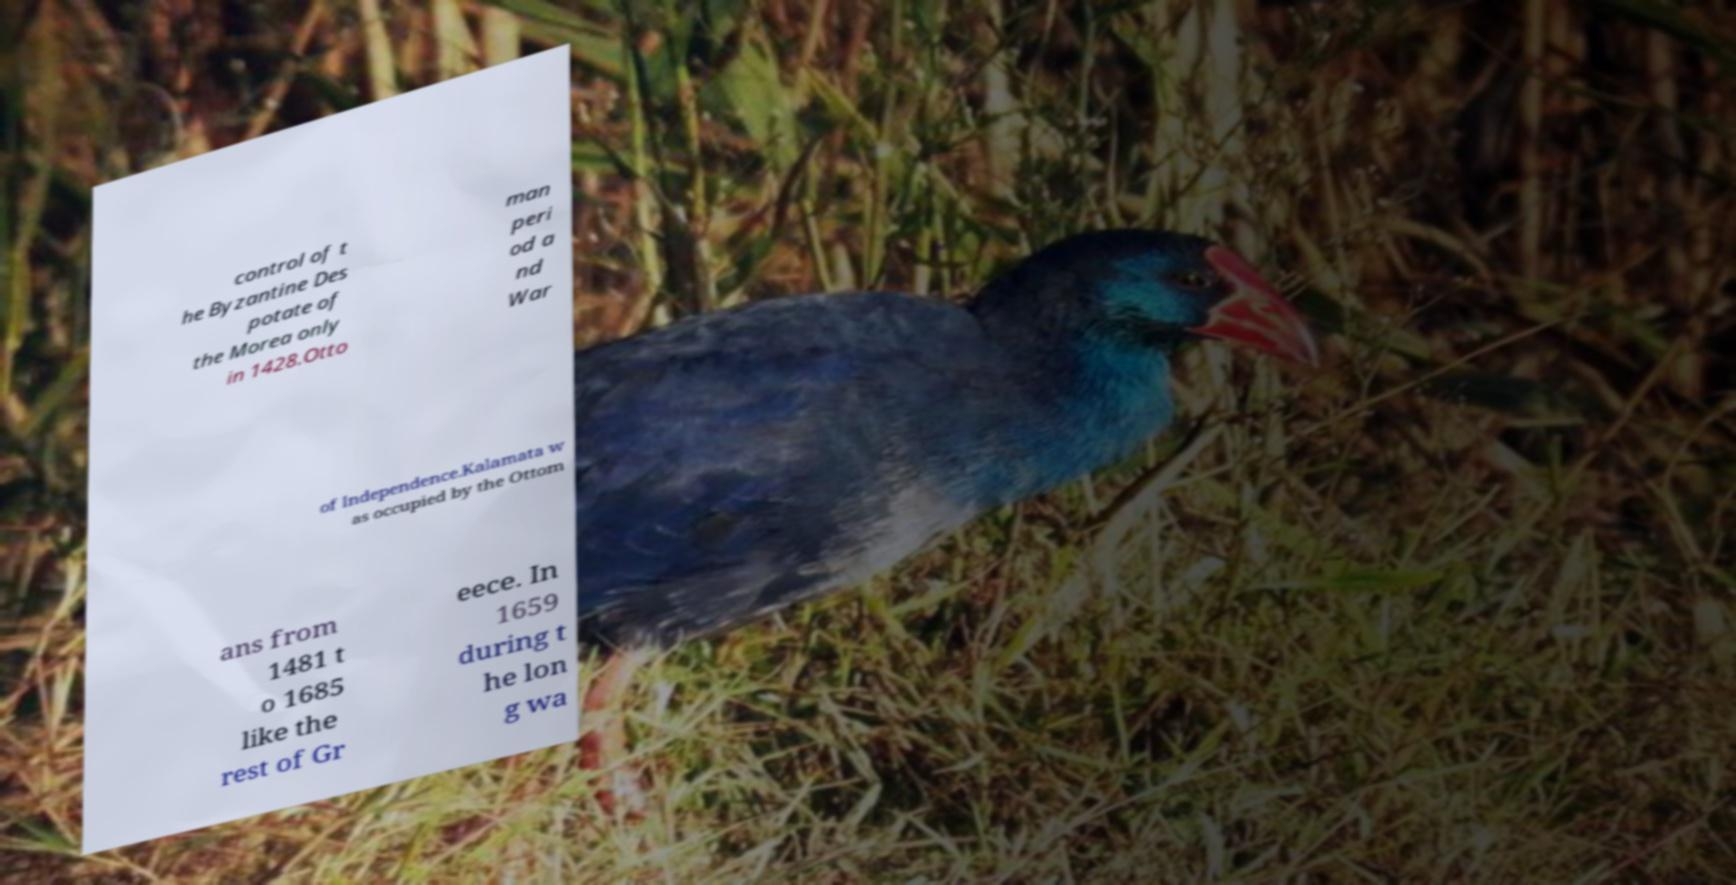Could you assist in decoding the text presented in this image and type it out clearly? control of t he Byzantine Des potate of the Morea only in 1428.Otto man peri od a nd War of Independence.Kalamata w as occupied by the Ottom ans from 1481 t o 1685 like the rest of Gr eece. In 1659 during t he lon g wa 